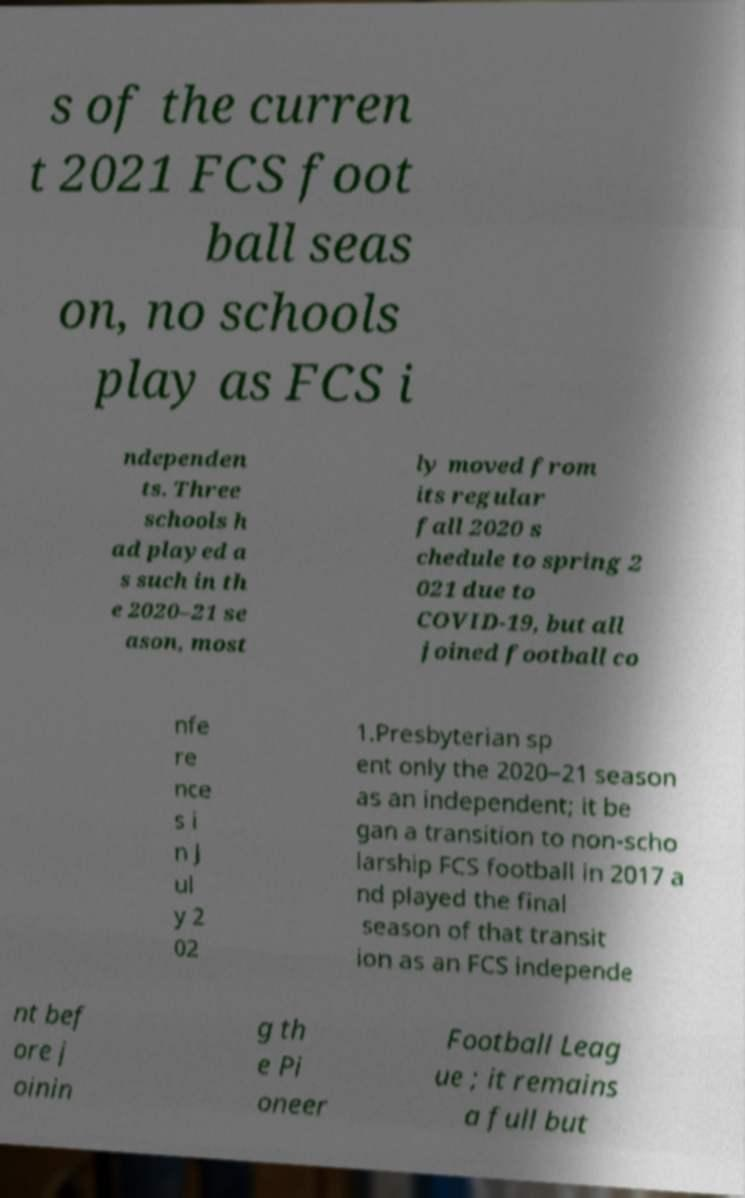Can you accurately transcribe the text from the provided image for me? s of the curren t 2021 FCS foot ball seas on, no schools play as FCS i ndependen ts. Three schools h ad played a s such in th e 2020–21 se ason, most ly moved from its regular fall 2020 s chedule to spring 2 021 due to COVID-19, but all joined football co nfe re nce s i n J ul y 2 02 1.Presbyterian sp ent only the 2020–21 season as an independent; it be gan a transition to non-scho larship FCS football in 2017 a nd played the final season of that transit ion as an FCS independe nt bef ore j oinin g th e Pi oneer Football Leag ue ; it remains a full but 